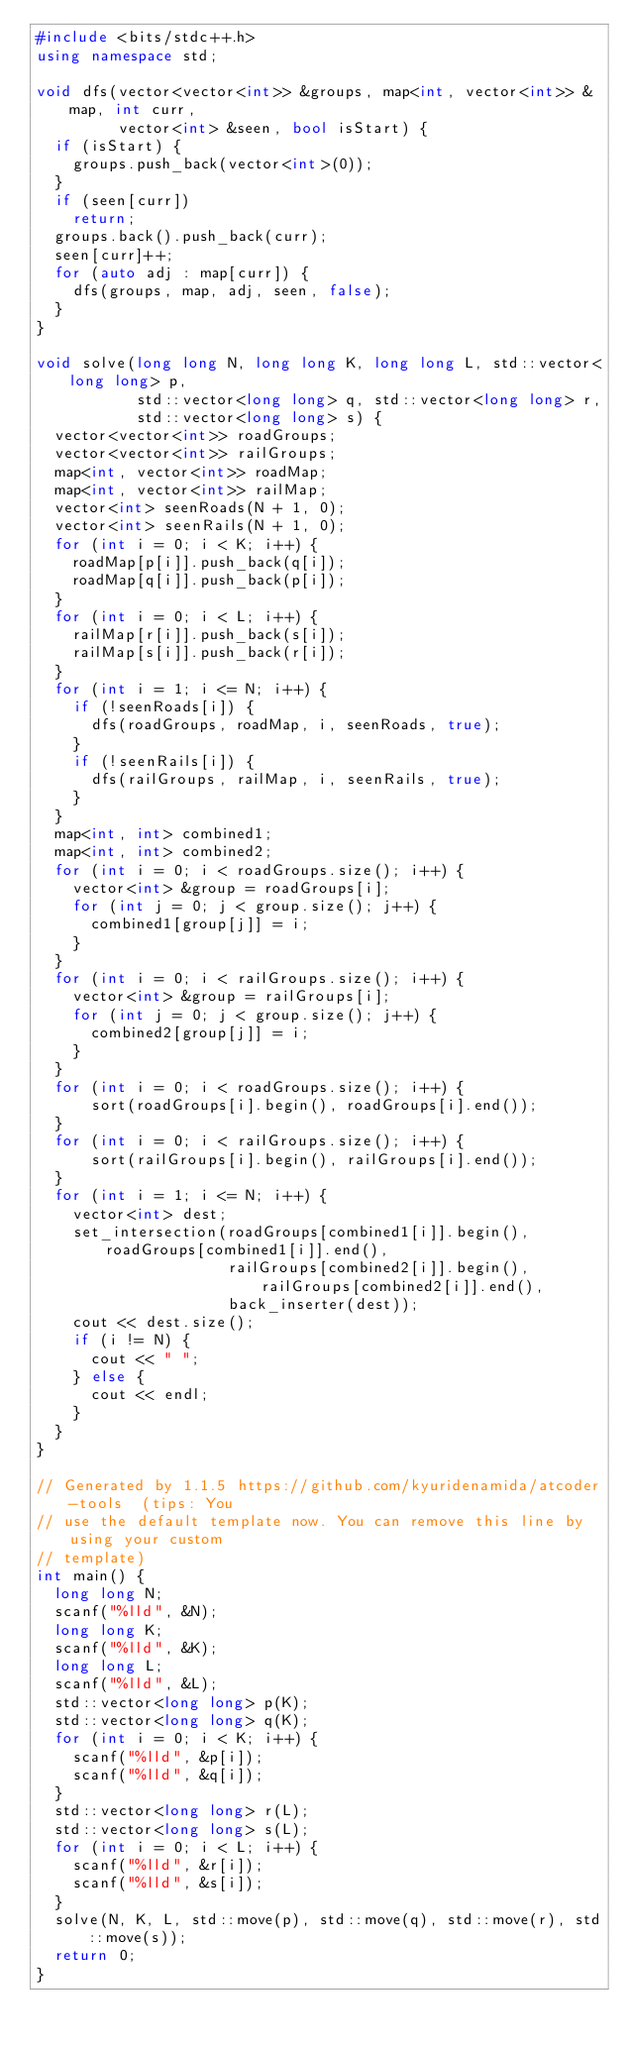<code> <loc_0><loc_0><loc_500><loc_500><_C++_>#include <bits/stdc++.h>
using namespace std;

void dfs(vector<vector<int>> &groups, map<int, vector<int>> &map, int curr,
         vector<int> &seen, bool isStart) {
  if (isStart) {
    groups.push_back(vector<int>(0));
  }
  if (seen[curr])
    return;
  groups.back().push_back(curr);
  seen[curr]++;
  for (auto adj : map[curr]) {
    dfs(groups, map, adj, seen, false);
  }
}

void solve(long long N, long long K, long long L, std::vector<long long> p,
           std::vector<long long> q, std::vector<long long> r,
           std::vector<long long> s) {
  vector<vector<int>> roadGroups;
  vector<vector<int>> railGroups;
  map<int, vector<int>> roadMap;
  map<int, vector<int>> railMap;
  vector<int> seenRoads(N + 1, 0);
  vector<int> seenRails(N + 1, 0);
  for (int i = 0; i < K; i++) {
    roadMap[p[i]].push_back(q[i]);
    roadMap[q[i]].push_back(p[i]);
  }
  for (int i = 0; i < L; i++) {
    railMap[r[i]].push_back(s[i]);
    railMap[s[i]].push_back(r[i]);
  }
  for (int i = 1; i <= N; i++) {
    if (!seenRoads[i]) {
      dfs(roadGroups, roadMap, i, seenRoads, true);
    }
    if (!seenRails[i]) {
      dfs(railGroups, railMap, i, seenRails, true);
    }
  }
  map<int, int> combined1;
  map<int, int> combined2;
  for (int i = 0; i < roadGroups.size(); i++) {
    vector<int> &group = roadGroups[i];
    for (int j = 0; j < group.size(); j++) {
      combined1[group[j]] = i;
    }
  }
  for (int i = 0; i < railGroups.size(); i++) {
    vector<int> &group = railGroups[i];
    for (int j = 0; j < group.size(); j++) {
      combined2[group[j]] = i;
    }
  }
  for (int i = 0; i < roadGroups.size(); i++) {
      sort(roadGroups[i].begin(), roadGroups[i].end());
  }
  for (int i = 0; i < railGroups.size(); i++) {
      sort(railGroups[i].begin(), railGroups[i].end());
  }
  for (int i = 1; i <= N; i++) {
    vector<int> dest;
    set_intersection(roadGroups[combined1[i]].begin(), roadGroups[combined1[i]].end(),
                     railGroups[combined2[i]].begin(), railGroups[combined2[i]].end(),
                     back_inserter(dest));
    cout << dest.size();
    if (i != N) {
      cout << " ";
    } else {
      cout << endl;
    }
  }
}

// Generated by 1.1.5 https://github.com/kyuridenamida/atcoder-tools  (tips: You
// use the default template now. You can remove this line by using your custom
// template)
int main() {
  long long N;
  scanf("%lld", &N);
  long long K;
  scanf("%lld", &K);
  long long L;
  scanf("%lld", &L);
  std::vector<long long> p(K);
  std::vector<long long> q(K);
  for (int i = 0; i < K; i++) {
    scanf("%lld", &p[i]);
    scanf("%lld", &q[i]);
  }
  std::vector<long long> r(L);
  std::vector<long long> s(L);
  for (int i = 0; i < L; i++) {
    scanf("%lld", &r[i]);
    scanf("%lld", &s[i]);
  }
  solve(N, K, L, std::move(p), std::move(q), std::move(r), std::move(s));
  return 0;
}
</code> 